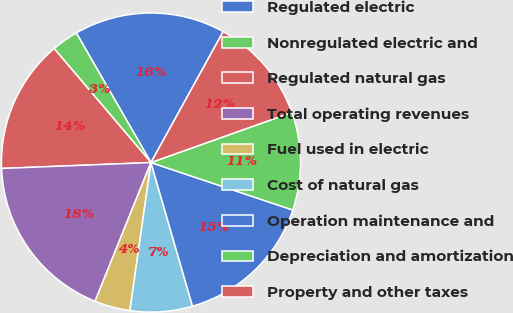Convert chart. <chart><loc_0><loc_0><loc_500><loc_500><pie_chart><fcel>Regulated electric<fcel>Nonregulated electric and<fcel>Regulated natural gas<fcel>Total operating revenues<fcel>Fuel used in electric<fcel>Cost of natural gas<fcel>Operation maintenance and<fcel>Depreciation and amortization<fcel>Property and other taxes<nl><fcel>16.34%<fcel>2.89%<fcel>14.42%<fcel>18.27%<fcel>3.85%<fcel>6.73%<fcel>15.38%<fcel>10.58%<fcel>11.54%<nl></chart> 